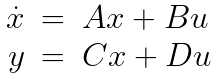<formula> <loc_0><loc_0><loc_500><loc_500>\begin{array} { r c l } \dot { x } & = & A x + B u \\ y & = & C x + D u \end{array}</formula> 